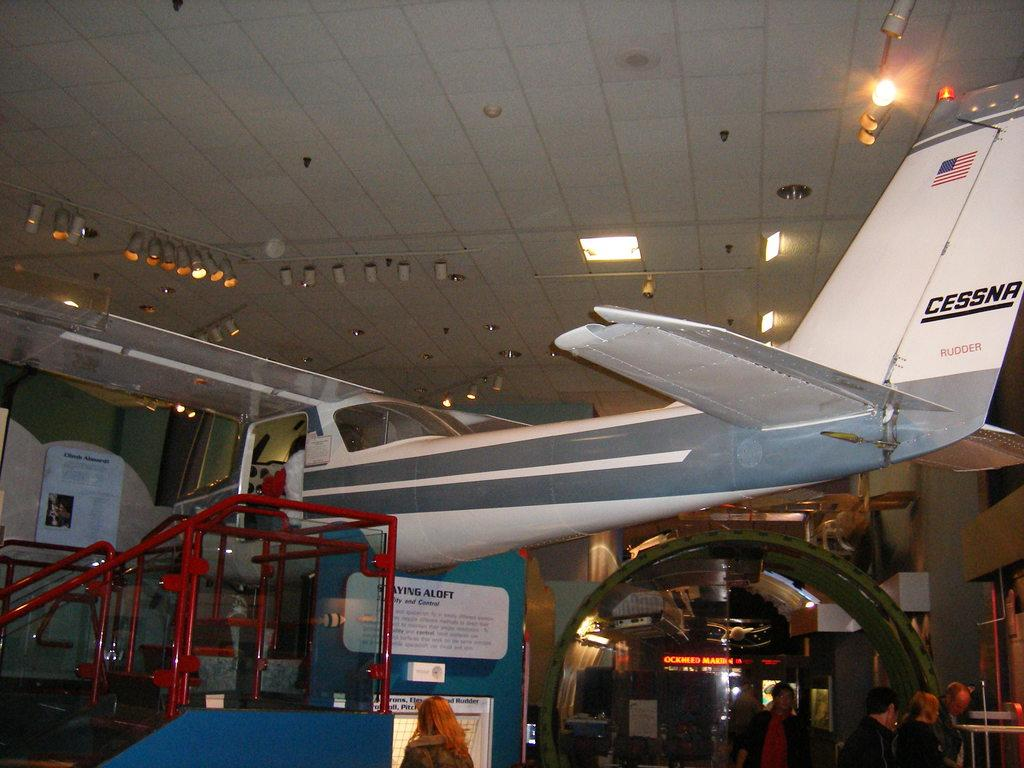<image>
Write a terse but informative summary of the picture. A Cessna plane is on display with red stairs leading up to it. 